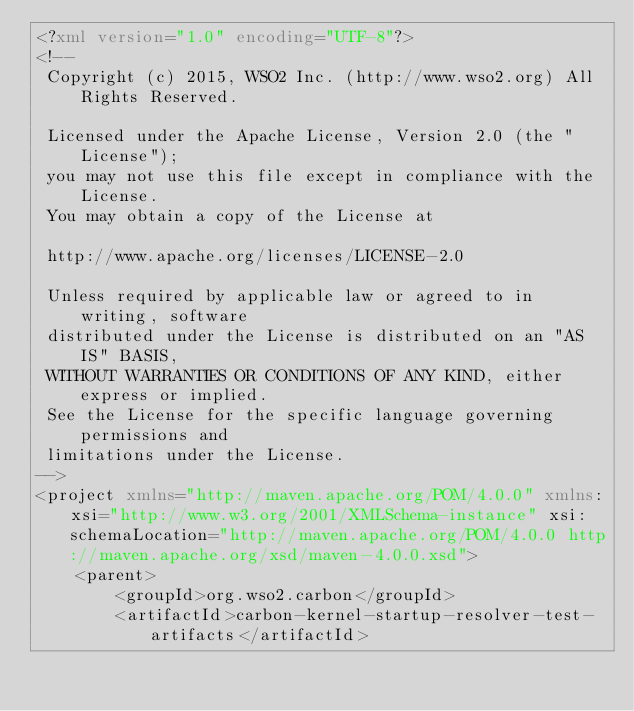Convert code to text. <code><loc_0><loc_0><loc_500><loc_500><_XML_><?xml version="1.0" encoding="UTF-8"?>
<!--
 Copyright (c) 2015, WSO2 Inc. (http://www.wso2.org) All Rights Reserved.

 Licensed under the Apache License, Version 2.0 (the "License");
 you may not use this file except in compliance with the License.
 You may obtain a copy of the License at

 http://www.apache.org/licenses/LICENSE-2.0

 Unless required by applicable law or agreed to in writing, software
 distributed under the License is distributed on an "AS IS" BASIS,
 WITHOUT WARRANTIES OR CONDITIONS OF ANY KIND, either express or implied.
 See the License for the specific language governing permissions and
 limitations under the License.
-->
<project xmlns="http://maven.apache.org/POM/4.0.0" xmlns:xsi="http://www.w3.org/2001/XMLSchema-instance" xsi:schemaLocation="http://maven.apache.org/POM/4.0.0 http://maven.apache.org/xsd/maven-4.0.0.xsd">
    <parent>
        <groupId>org.wso2.carbon</groupId>
        <artifactId>carbon-kernel-startup-resolver-test-artifacts</artifactId></code> 